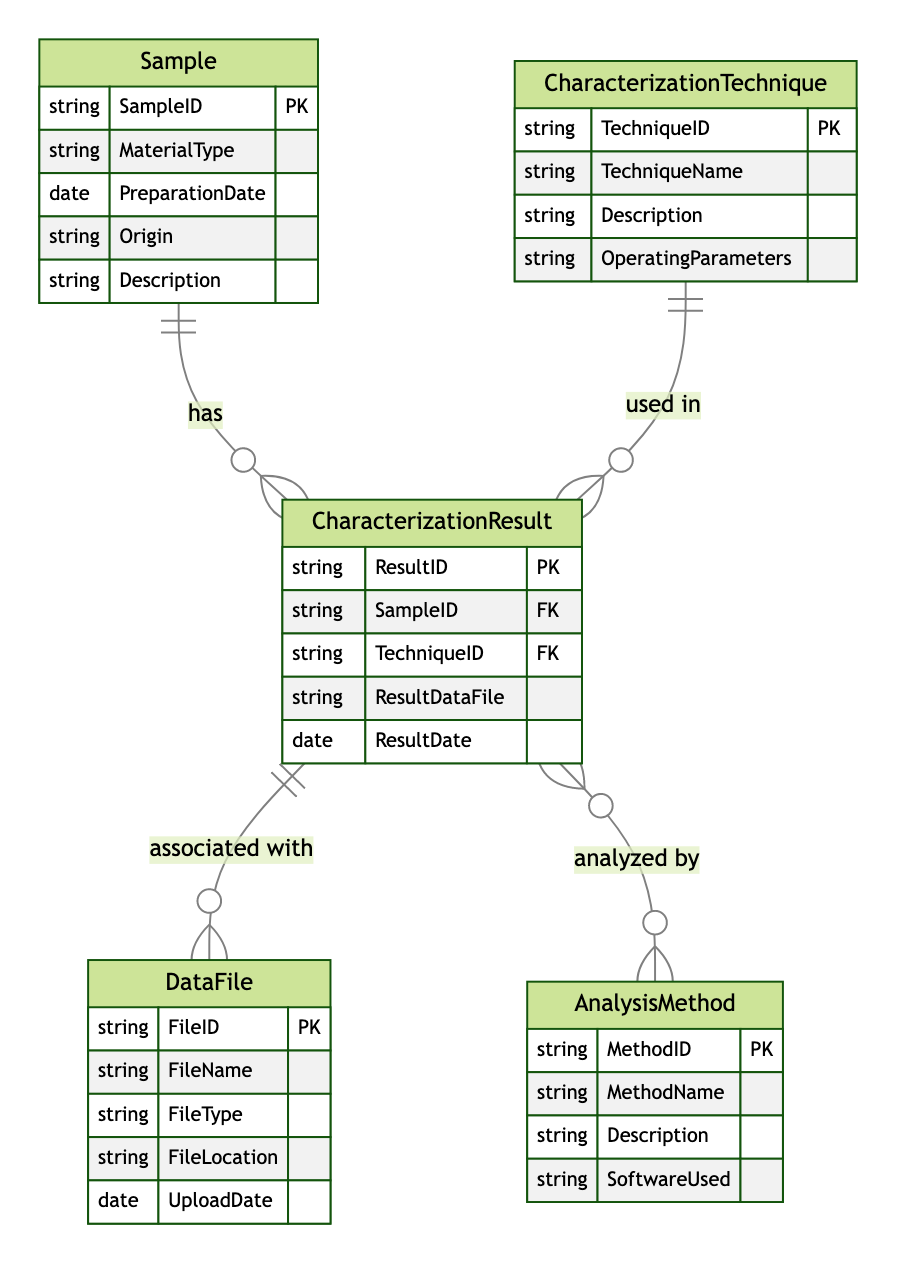What is the primary key of the Sample entity? The primary key of the Sample entity is SampleID, as indicated by the attributes listed for the Sample in the diagram.
Answer: SampleID How many characterization techniques are represented in the diagram? The diagram features one entity for CharacterizationTechnique, meaning there can potentially be multiple techniques, although their count is not specified in the diagram itself. Therefore, it can be assumed to be one without specific numbers stated.
Answer: One What type of relationship exists between CharacterizationResult and DataFile? The relationship between CharacterizationResult and DataFile is "one-to-many," indicating that each CharacterizationResult can be linked to multiple DataFiles.
Answer: One-to-many What is the cardinality of the relationship between CharacterizationResult and CharacterizationTechnique? The cardinality of the relationship between CharacterizationResult and CharacterizationTechnique is "many-to-one," signifying that multiple characterization results can utilize a single technique.
Answer: Many-to-one Which entity is analyzed by multiple methods according to the diagram? The CharacterizationResult entity is analyzed by multiple methods, as indicated by the many-to-many relationship depicted in the diagram.
Answer: CharacterizationResult What does the DataFile entity describe? The DataFile entity describes files associated with characterization results, specifically detailing attributes like FileName, FileType, FileLocation, and UploadDate.
Answer: Data associated with results How many entities are there in total? There are five entities in the diagram: Sample, CharacterizationTechnique, CharacterizationResult, DataFile, and AnalysisMethod.
Answer: Five Which relationship indicates how samples can have multiple characterization results? The relationship named "Sample_Has_Result" explicitly shows that each sample can have multiple characterization results.
Answer: Sample_Has_Result What is the relationship between CharacterizationResult and AnalysisMethod? The relationship between CharacterizationResult and AnalysisMethod is "many-to-many," indicating that characterization results can be analyzed by various methods, and each method can apply to multiple results.
Answer: Many-to-many Which entity serves as the primary key for the AnalysisMethod? The primary key for the AnalysisMethod entity is MethodID, as shown in the attributes of the AnalysisMethod entity within the diagram.
Answer: MethodID 